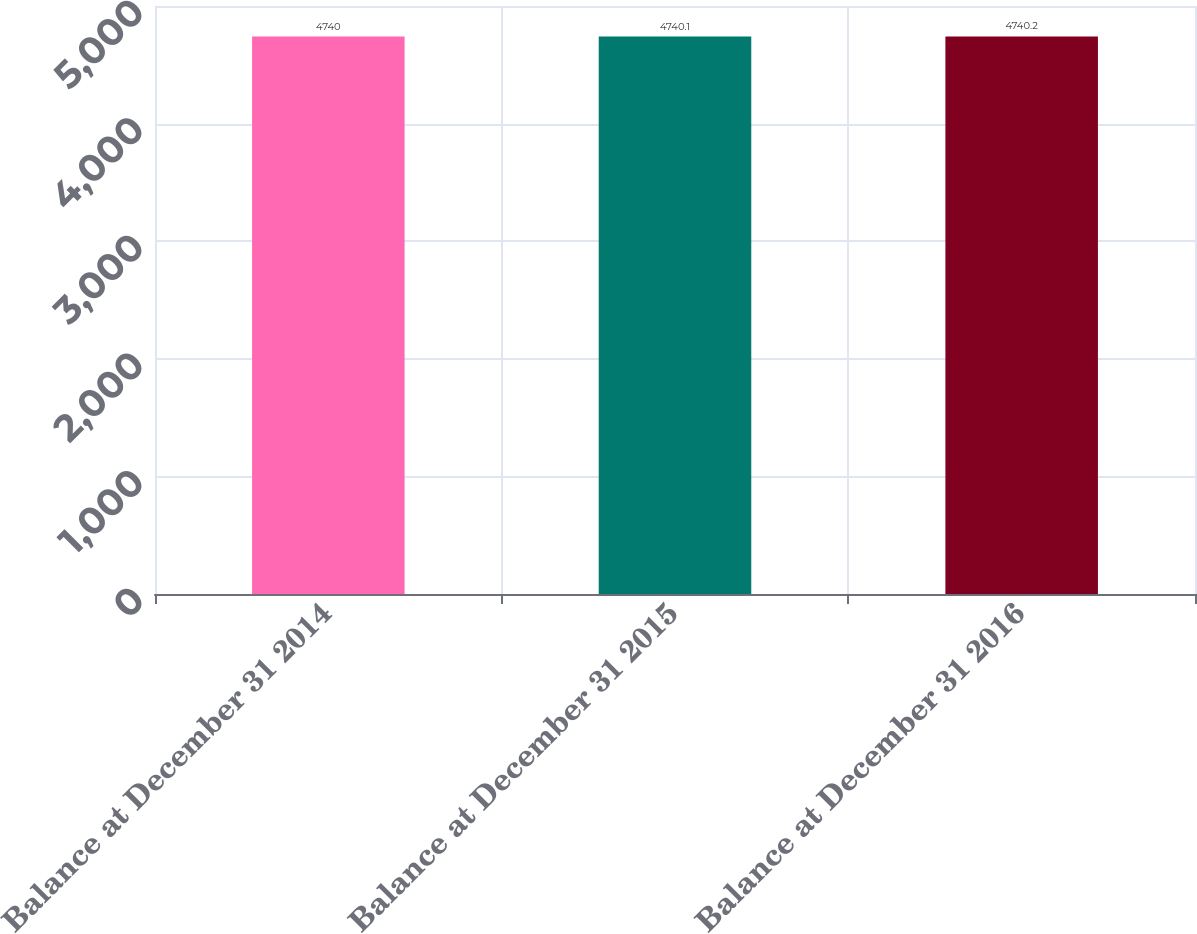<chart> <loc_0><loc_0><loc_500><loc_500><bar_chart><fcel>Balance at December 31 2014<fcel>Balance at December 31 2015<fcel>Balance at December 31 2016<nl><fcel>4740<fcel>4740.1<fcel>4740.2<nl></chart> 